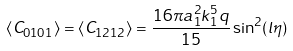<formula> <loc_0><loc_0><loc_500><loc_500>\langle C _ { 0 1 0 1 } \rangle = \langle C _ { 1 2 1 2 } \rangle = \frac { 1 6 \pi a _ { 1 } ^ { 2 } k _ { 1 } ^ { 5 } q } { 1 5 } \sin ^ { 2 } ( l \eta )</formula> 